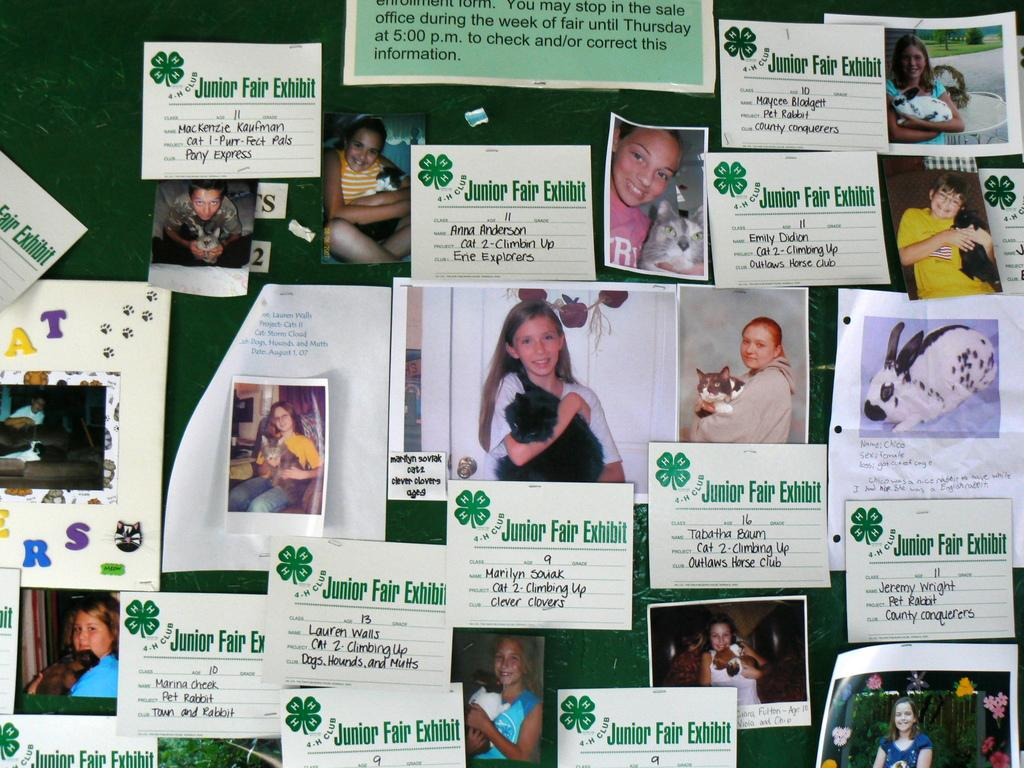What is the main object in the image? There is a board in the image. What is on the board? There are photos and texted papers on the board. Can you describe the content of the photos and papers? Unfortunately, the details of the photos and papers are not visible in the image, so we cannot describe their content. What type of hobbies are the people in the image engaged in? There are no people visible in the image, so we cannot determine the hobbies they might be engaged in. 